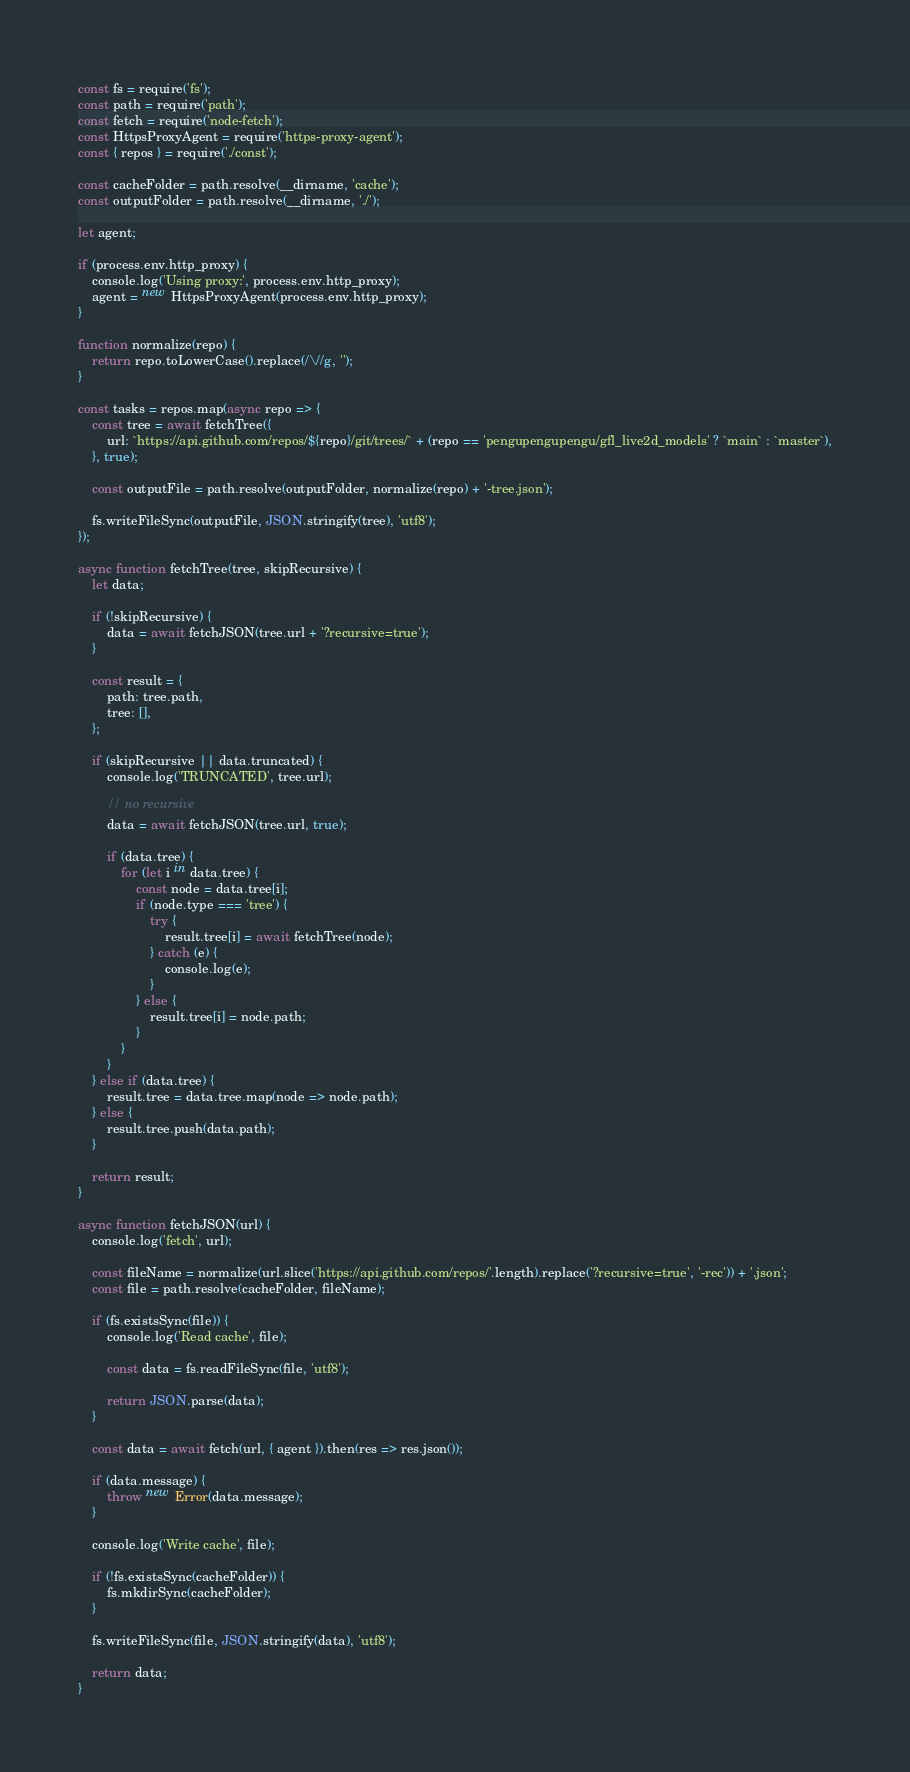<code> <loc_0><loc_0><loc_500><loc_500><_JavaScript_>const fs = require('fs');
const path = require('path');
const fetch = require('node-fetch');
const HttpsProxyAgent = require('https-proxy-agent');
const { repos } = require('./const');

const cacheFolder = path.resolve(__dirname, 'cache');
const outputFolder = path.resolve(__dirname, './');

let agent;

if (process.env.http_proxy) {
    console.log('Using proxy:', process.env.http_proxy);
    agent = new HttpsProxyAgent(process.env.http_proxy);
}

function normalize(repo) {
    return repo.toLowerCase().replace(/\//g, '');
}

const tasks = repos.map(async repo => {
    const tree = await fetchTree({
        url: `https://api.github.com/repos/${repo}/git/trees/` + (repo == 'pengupengupengu/gfl_live2d_models' ? `main` : `master`),
    }, true);

    const outputFile = path.resolve(outputFolder, normalize(repo) + '-tree.json');

    fs.writeFileSync(outputFile, JSON.stringify(tree), 'utf8');
});

async function fetchTree(tree, skipRecursive) {
    let data;

    if (!skipRecursive) {
        data = await fetchJSON(tree.url + '?recursive=true');
    }

    const result = {
        path: tree.path,
        tree: [],
    };

    if (skipRecursive || data.truncated) {
        console.log('TRUNCATED', tree.url);

        // no recursive
        data = await fetchJSON(tree.url, true);

        if (data.tree) {
            for (let i in data.tree) {
                const node = data.tree[i];
                if (node.type === 'tree') {
                    try {
                        result.tree[i] = await fetchTree(node);
                    } catch (e) {
                        console.log(e);
                    }
                } else {
                    result.tree[i] = node.path;
                }
            }
        }
    } else if (data.tree) {
        result.tree = data.tree.map(node => node.path);
    } else {
        result.tree.push(data.path);
    }

    return result;
}

async function fetchJSON(url) {
    console.log('fetch', url);

    const fileName = normalize(url.slice('https://api.github.com/repos/'.length).replace('?recursive=true', '-rec')) + '.json';
    const file = path.resolve(cacheFolder, fileName);

    if (fs.existsSync(file)) {
        console.log('Read cache', file);

        const data = fs.readFileSync(file, 'utf8');

        return JSON.parse(data);
    }

    const data = await fetch(url, { agent }).then(res => res.json());

    if (data.message) {
        throw new Error(data.message);
    }

    console.log('Write cache', file);

    if (!fs.existsSync(cacheFolder)) {
        fs.mkdirSync(cacheFolder);
    }

    fs.writeFileSync(file, JSON.stringify(data), 'utf8');

    return data;
}
</code> 